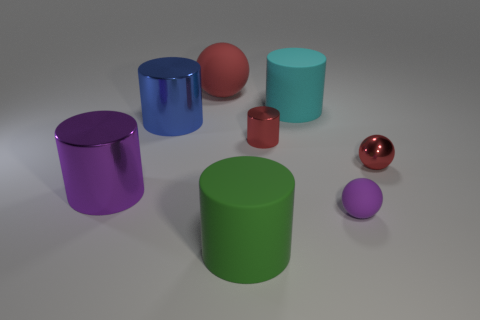Is there any indication of the scale or sizes of these objects? The image doesn't provide a reference point for scale, but the objects range from small to larger cylinders and spheres, which could be anywhere from a few centimeters to several inches in diameter. 